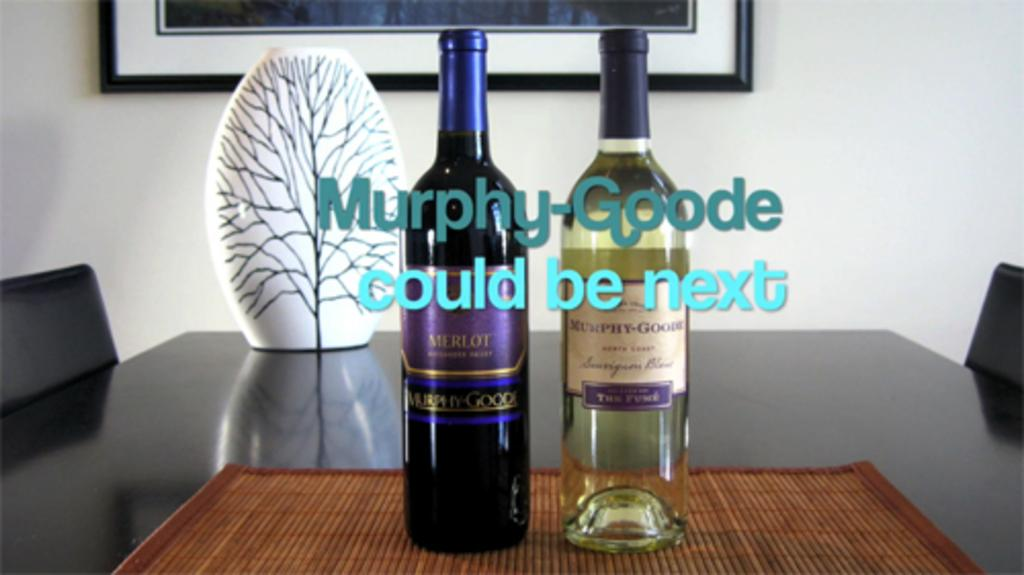<image>
Summarize the visual content of the image. Two bottles of Murphy-Goode wine bottles are displayed on a conference table. 